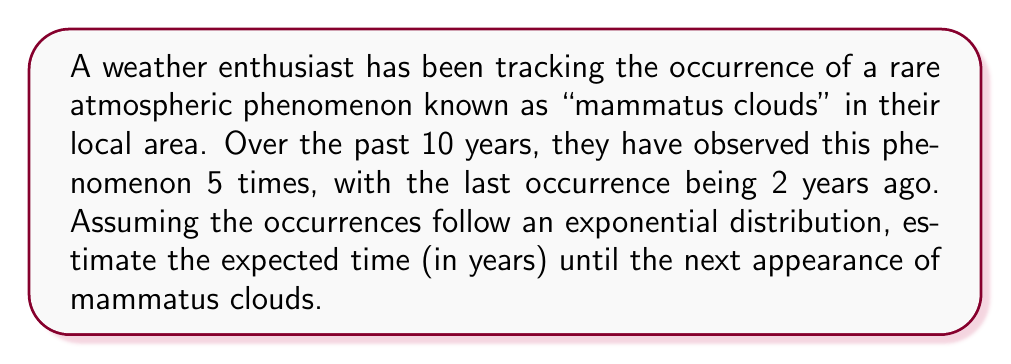Give your solution to this math problem. To solve this problem, we'll use survival analysis and the properties of the exponential distribution:

1) The exponential distribution is often used in survival analysis to model the time between events.

2) For an exponential distribution, the rate parameter λ is the inverse of the mean time between events.

3) We can estimate λ using the observed data:
   λ = (number of events) / (total observation time)
   λ = 5 / 10 = 0.5 events per year

4) The expected time until the next event in an exponential distribution is given by 1/λ.

5) However, we need to account for the time that has already passed since the last event (2 years). Due to the memoryless property of the exponential distribution, this doesn't change our calculation.

6) Therefore, the expected time until the next occurrence is:
   E(T) = 1 / λ = 1 / 0.5 = 2 years

So, from the current time, we expect to wait an additional 2 years on average for the next appearance of mammatus clouds.
Answer: 2 years 